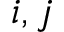Convert formula to latex. <formula><loc_0><loc_0><loc_500><loc_500>i , j</formula> 